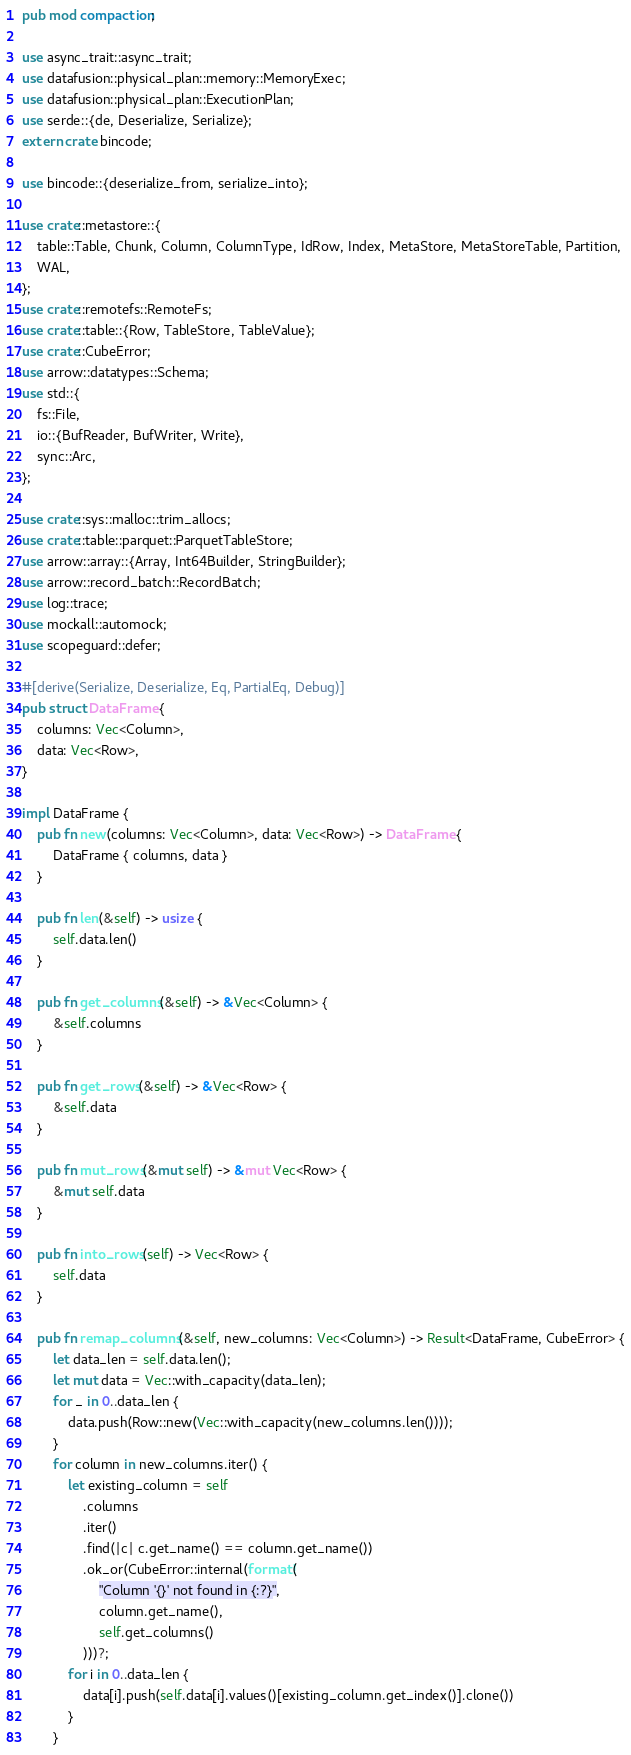Convert code to text. <code><loc_0><loc_0><loc_500><loc_500><_Rust_>pub mod compaction;

use async_trait::async_trait;
use datafusion::physical_plan::memory::MemoryExec;
use datafusion::physical_plan::ExecutionPlan;
use serde::{de, Deserialize, Serialize};
extern crate bincode;

use bincode::{deserialize_from, serialize_into};

use crate::metastore::{
    table::Table, Chunk, Column, ColumnType, IdRow, Index, MetaStore, MetaStoreTable, Partition,
    WAL,
};
use crate::remotefs::RemoteFs;
use crate::table::{Row, TableStore, TableValue};
use crate::CubeError;
use arrow::datatypes::Schema;
use std::{
    fs::File,
    io::{BufReader, BufWriter, Write},
    sync::Arc,
};

use crate::sys::malloc::trim_allocs;
use crate::table::parquet::ParquetTableStore;
use arrow::array::{Array, Int64Builder, StringBuilder};
use arrow::record_batch::RecordBatch;
use log::trace;
use mockall::automock;
use scopeguard::defer;

#[derive(Serialize, Deserialize, Eq, PartialEq, Debug)]
pub struct DataFrame {
    columns: Vec<Column>,
    data: Vec<Row>,
}

impl DataFrame {
    pub fn new(columns: Vec<Column>, data: Vec<Row>) -> DataFrame {
        DataFrame { columns, data }
    }

    pub fn len(&self) -> usize {
        self.data.len()
    }

    pub fn get_columns(&self) -> &Vec<Column> {
        &self.columns
    }

    pub fn get_rows(&self) -> &Vec<Row> {
        &self.data
    }

    pub fn mut_rows(&mut self) -> &mut Vec<Row> {
        &mut self.data
    }

    pub fn into_rows(self) -> Vec<Row> {
        self.data
    }

    pub fn remap_columns(&self, new_columns: Vec<Column>) -> Result<DataFrame, CubeError> {
        let data_len = self.data.len();
        let mut data = Vec::with_capacity(data_len);
        for _ in 0..data_len {
            data.push(Row::new(Vec::with_capacity(new_columns.len())));
        }
        for column in new_columns.iter() {
            let existing_column = self
                .columns
                .iter()
                .find(|c| c.get_name() == column.get_name())
                .ok_or(CubeError::internal(format!(
                    "Column '{}' not found in {:?}",
                    column.get_name(),
                    self.get_columns()
                )))?;
            for i in 0..data_len {
                data[i].push(self.data[i].values()[existing_column.get_index()].clone())
            }
        }</code> 